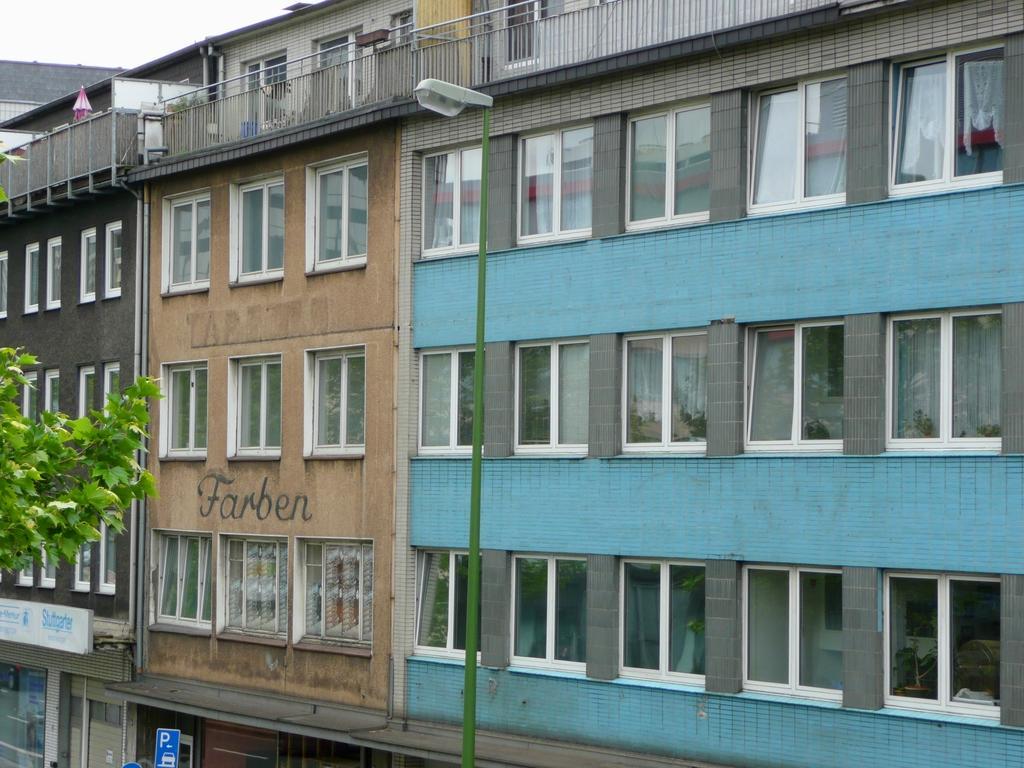How would you summarize this image in a sentence or two? In this image, I can see the buildings with the windows. This is a street light. On the left side of the image, I think this is a tree with the branches and leaves. At the bottom of the image, that looks like a signboard. This is a name board, which is attached to a building. At the top of the image, these look like the barricades, which are at the top of the buildings. 